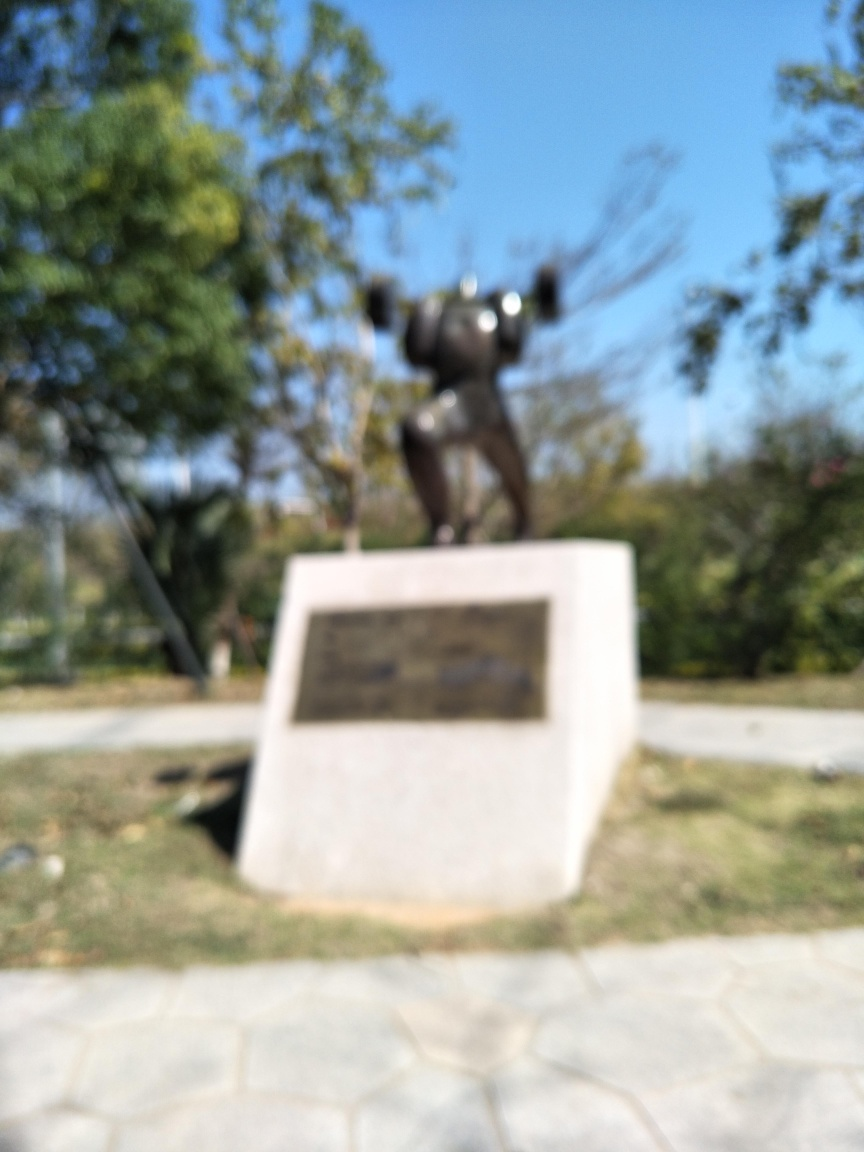Does the quality of this image look very poor?
A. No
B. Yes
Answer with the option's letter from the given choices directly.
 B. 